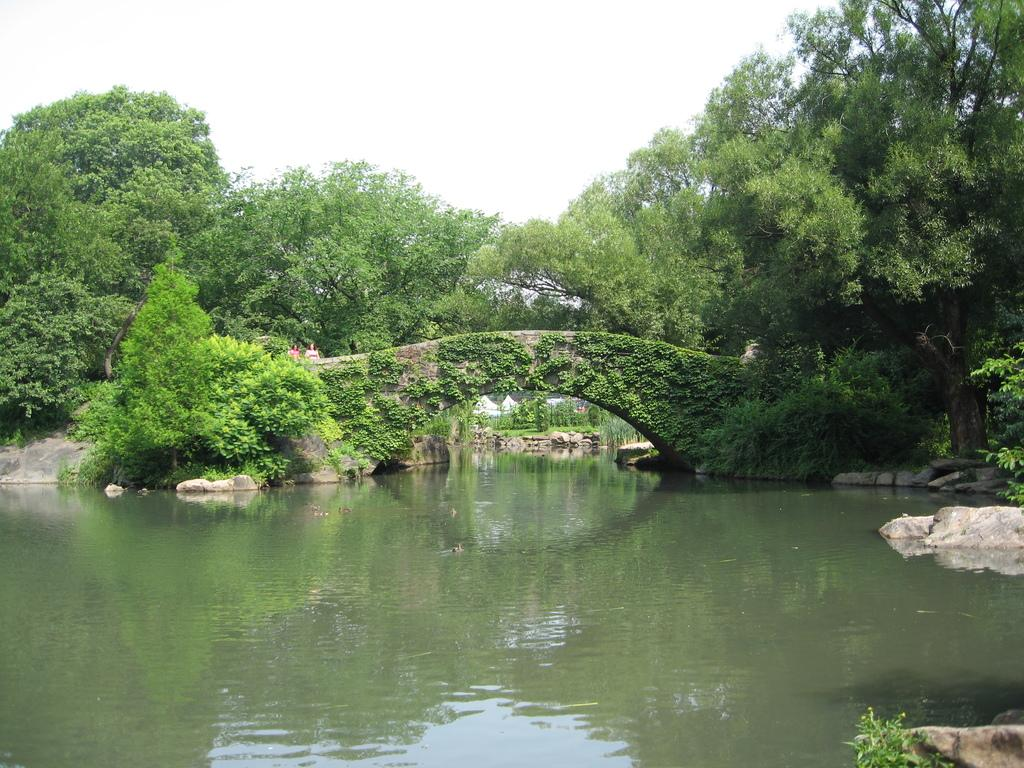What is the main feature of the image? The main feature of the image is water. What structure can be seen in the middle of the image? There is a bridge in the middle of the image. What type of vegetation is present in the image? There are green trees in the image. What is visible at the top of the image? The sky is visible at the top of the image. What time is the library closing in the image? There is no reference to a library or any time-related information in the image. 